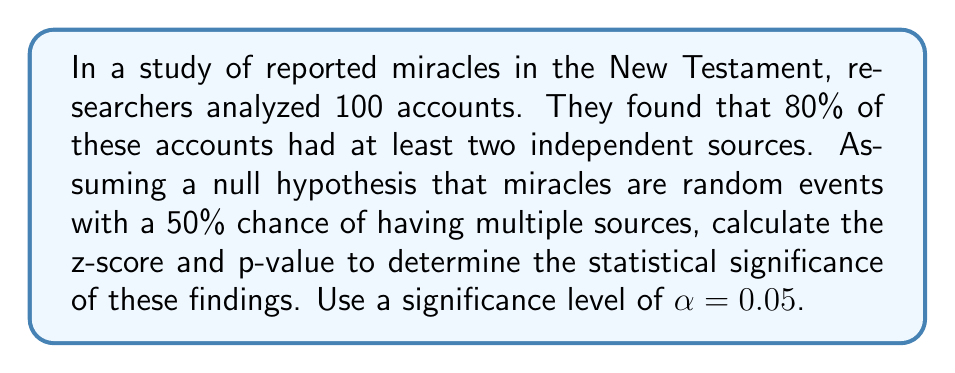Give your solution to this math problem. As an enthusiastic young theologian interested in Christian apologetics and historical evidence, this problem allows us to apply statistical methods to evaluate the significance of reported miracles.

Let's approach this step-by-step:

1) First, we need to identify our parameters:
   n = 100 (sample size)
   p̂ = 0.80 (sample proportion)
   p₀ = 0.50 (null hypothesis proportion)

2) We'll use the z-test for a single proportion. The formula for the z-score is:

   $$ z = \frac{\hat{p} - p_0}{\sqrt{\frac{p_0(1-p_0)}{n}}} $$

3) Let's substitute our values:

   $$ z = \frac{0.80 - 0.50}{\sqrt{\frac{0.50(1-0.50)}{100}}} $$

4) Simplify:
   $$ z = \frac{0.30}{\sqrt{\frac{0.25}{100}}} = \frac{0.30}{0.05} = 6 $$

5) Now that we have our z-score, we need to find the p-value. The p-value is the probability of obtaining results at least as extreme as the observed results, assuming the null hypothesis is true.

6) For a two-tailed test (which we use here as we're not specifying a direction), we need to find the area under both tails of the normal distribution beyond z = 6 and z = -6.

7) Using a standard normal distribution table or calculator, we find:
   P(Z > 6) ≈ 9.87 × 10⁻¹⁰
   
8) For a two-tailed test, we double this value:
   p-value ≈ 2 × (9.87 × 10⁻¹⁰) ≈ 1.97 × 10⁻⁹

9) Compare this to our significance level α = 0.05:
   1.97 × 10⁻⁹ < 0.05

Therefore, we reject the null hypothesis. The data suggests that the proportion of miracle accounts with multiple sources is significantly different from what would be expected by chance alone.
Answer: z-score ≈ 6
p-value ≈ 1.97 × 10⁻⁹
The result is statistically significant at α = 0.05. 